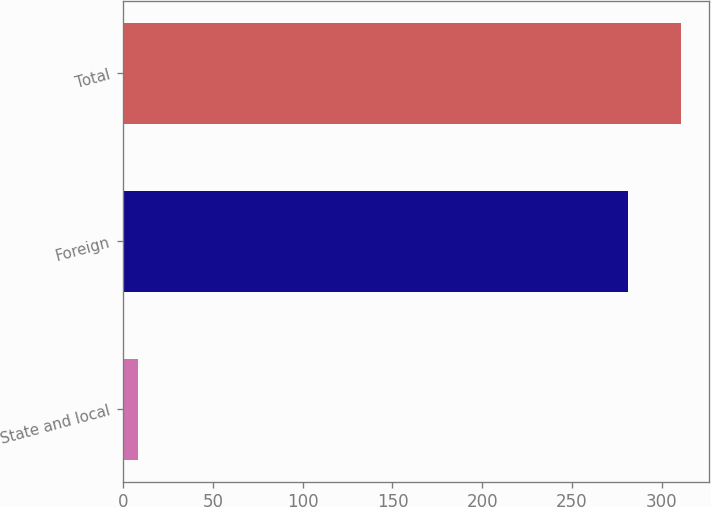<chart> <loc_0><loc_0><loc_500><loc_500><bar_chart><fcel>State and local<fcel>Foreign<fcel>Total<nl><fcel>8<fcel>281<fcel>310.6<nl></chart> 